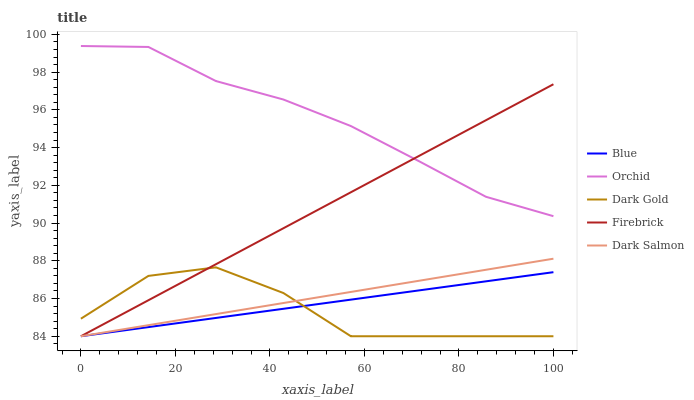Does Dark Gold have the minimum area under the curve?
Answer yes or no. Yes. Does Orchid have the maximum area under the curve?
Answer yes or no. Yes. Does Firebrick have the minimum area under the curve?
Answer yes or no. No. Does Firebrick have the maximum area under the curve?
Answer yes or no. No. Is Firebrick the smoothest?
Answer yes or no. Yes. Is Dark Gold the roughest?
Answer yes or no. Yes. Is Dark Gold the smoothest?
Answer yes or no. No. Is Firebrick the roughest?
Answer yes or no. No. Does Blue have the lowest value?
Answer yes or no. Yes. Does Orchid have the lowest value?
Answer yes or no. No. Does Orchid have the highest value?
Answer yes or no. Yes. Does Firebrick have the highest value?
Answer yes or no. No. Is Dark Gold less than Orchid?
Answer yes or no. Yes. Is Orchid greater than Blue?
Answer yes or no. Yes. Does Firebrick intersect Blue?
Answer yes or no. Yes. Is Firebrick less than Blue?
Answer yes or no. No. Is Firebrick greater than Blue?
Answer yes or no. No. Does Dark Gold intersect Orchid?
Answer yes or no. No. 